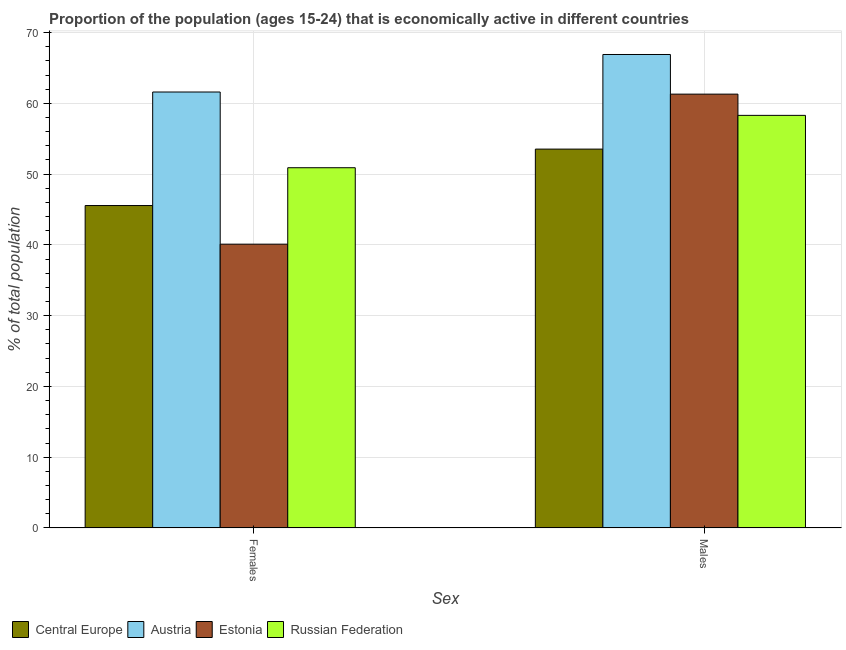How many different coloured bars are there?
Keep it short and to the point. 4. Are the number of bars on each tick of the X-axis equal?
Ensure brevity in your answer.  Yes. What is the label of the 2nd group of bars from the left?
Your answer should be compact. Males. What is the percentage of economically active male population in Estonia?
Make the answer very short. 61.3. Across all countries, what is the maximum percentage of economically active female population?
Offer a very short reply. 61.6. Across all countries, what is the minimum percentage of economically active female population?
Offer a very short reply. 40.1. In which country was the percentage of economically active female population maximum?
Ensure brevity in your answer.  Austria. In which country was the percentage of economically active female population minimum?
Offer a very short reply. Estonia. What is the total percentage of economically active male population in the graph?
Your answer should be very brief. 240.03. What is the difference between the percentage of economically active male population in Russian Federation and that in Estonia?
Your answer should be compact. -3. What is the difference between the percentage of economically active female population in Central Europe and the percentage of economically active male population in Estonia?
Make the answer very short. -15.74. What is the average percentage of economically active female population per country?
Offer a very short reply. 49.54. What is the difference between the percentage of economically active male population and percentage of economically active female population in Russian Federation?
Give a very brief answer. 7.4. What is the ratio of the percentage of economically active female population in Russian Federation to that in Estonia?
Keep it short and to the point. 1.27. In how many countries, is the percentage of economically active male population greater than the average percentage of economically active male population taken over all countries?
Keep it short and to the point. 2. What does the 4th bar from the left in Females represents?
Keep it short and to the point. Russian Federation. What does the 2nd bar from the right in Females represents?
Ensure brevity in your answer.  Estonia. Are all the bars in the graph horizontal?
Offer a terse response. No. How many countries are there in the graph?
Your answer should be compact. 4. Does the graph contain grids?
Make the answer very short. Yes. What is the title of the graph?
Your answer should be compact. Proportion of the population (ages 15-24) that is economically active in different countries. Does "Togo" appear as one of the legend labels in the graph?
Make the answer very short. No. What is the label or title of the X-axis?
Offer a terse response. Sex. What is the label or title of the Y-axis?
Make the answer very short. % of total population. What is the % of total population in Central Europe in Females?
Keep it short and to the point. 45.56. What is the % of total population in Austria in Females?
Your answer should be compact. 61.6. What is the % of total population in Estonia in Females?
Ensure brevity in your answer.  40.1. What is the % of total population of Russian Federation in Females?
Ensure brevity in your answer.  50.9. What is the % of total population in Central Europe in Males?
Offer a terse response. 53.53. What is the % of total population of Austria in Males?
Provide a succinct answer. 66.9. What is the % of total population in Estonia in Males?
Keep it short and to the point. 61.3. What is the % of total population in Russian Federation in Males?
Your answer should be very brief. 58.3. Across all Sex, what is the maximum % of total population in Central Europe?
Provide a short and direct response. 53.53. Across all Sex, what is the maximum % of total population in Austria?
Provide a succinct answer. 66.9. Across all Sex, what is the maximum % of total population of Estonia?
Provide a succinct answer. 61.3. Across all Sex, what is the maximum % of total population of Russian Federation?
Offer a very short reply. 58.3. Across all Sex, what is the minimum % of total population of Central Europe?
Offer a very short reply. 45.56. Across all Sex, what is the minimum % of total population of Austria?
Provide a short and direct response. 61.6. Across all Sex, what is the minimum % of total population of Estonia?
Provide a succinct answer. 40.1. Across all Sex, what is the minimum % of total population of Russian Federation?
Keep it short and to the point. 50.9. What is the total % of total population in Central Europe in the graph?
Your answer should be compact. 99.09. What is the total % of total population of Austria in the graph?
Provide a succinct answer. 128.5. What is the total % of total population of Estonia in the graph?
Your answer should be very brief. 101.4. What is the total % of total population in Russian Federation in the graph?
Provide a succinct answer. 109.2. What is the difference between the % of total population in Central Europe in Females and that in Males?
Your answer should be very brief. -7.97. What is the difference between the % of total population in Estonia in Females and that in Males?
Give a very brief answer. -21.2. What is the difference between the % of total population of Central Europe in Females and the % of total population of Austria in Males?
Your response must be concise. -21.34. What is the difference between the % of total population in Central Europe in Females and the % of total population in Estonia in Males?
Make the answer very short. -15.74. What is the difference between the % of total population of Central Europe in Females and the % of total population of Russian Federation in Males?
Make the answer very short. -12.74. What is the difference between the % of total population of Austria in Females and the % of total population of Estonia in Males?
Keep it short and to the point. 0.3. What is the difference between the % of total population of Estonia in Females and the % of total population of Russian Federation in Males?
Keep it short and to the point. -18.2. What is the average % of total population in Central Europe per Sex?
Provide a short and direct response. 49.54. What is the average % of total population of Austria per Sex?
Offer a terse response. 64.25. What is the average % of total population in Estonia per Sex?
Your response must be concise. 50.7. What is the average % of total population in Russian Federation per Sex?
Offer a terse response. 54.6. What is the difference between the % of total population of Central Europe and % of total population of Austria in Females?
Make the answer very short. -16.04. What is the difference between the % of total population in Central Europe and % of total population in Estonia in Females?
Ensure brevity in your answer.  5.46. What is the difference between the % of total population of Central Europe and % of total population of Russian Federation in Females?
Give a very brief answer. -5.34. What is the difference between the % of total population of Estonia and % of total population of Russian Federation in Females?
Give a very brief answer. -10.8. What is the difference between the % of total population in Central Europe and % of total population in Austria in Males?
Your answer should be compact. -13.37. What is the difference between the % of total population of Central Europe and % of total population of Estonia in Males?
Your answer should be very brief. -7.77. What is the difference between the % of total population of Central Europe and % of total population of Russian Federation in Males?
Ensure brevity in your answer.  -4.77. What is the difference between the % of total population in Austria and % of total population in Russian Federation in Males?
Provide a succinct answer. 8.6. What is the ratio of the % of total population of Central Europe in Females to that in Males?
Keep it short and to the point. 0.85. What is the ratio of the % of total population in Austria in Females to that in Males?
Your response must be concise. 0.92. What is the ratio of the % of total population in Estonia in Females to that in Males?
Provide a succinct answer. 0.65. What is the ratio of the % of total population of Russian Federation in Females to that in Males?
Give a very brief answer. 0.87. What is the difference between the highest and the second highest % of total population of Central Europe?
Offer a terse response. 7.97. What is the difference between the highest and the second highest % of total population of Estonia?
Keep it short and to the point. 21.2. What is the difference between the highest and the second highest % of total population of Russian Federation?
Provide a succinct answer. 7.4. What is the difference between the highest and the lowest % of total population of Central Europe?
Provide a succinct answer. 7.97. What is the difference between the highest and the lowest % of total population in Austria?
Provide a succinct answer. 5.3. What is the difference between the highest and the lowest % of total population in Estonia?
Your answer should be very brief. 21.2. 